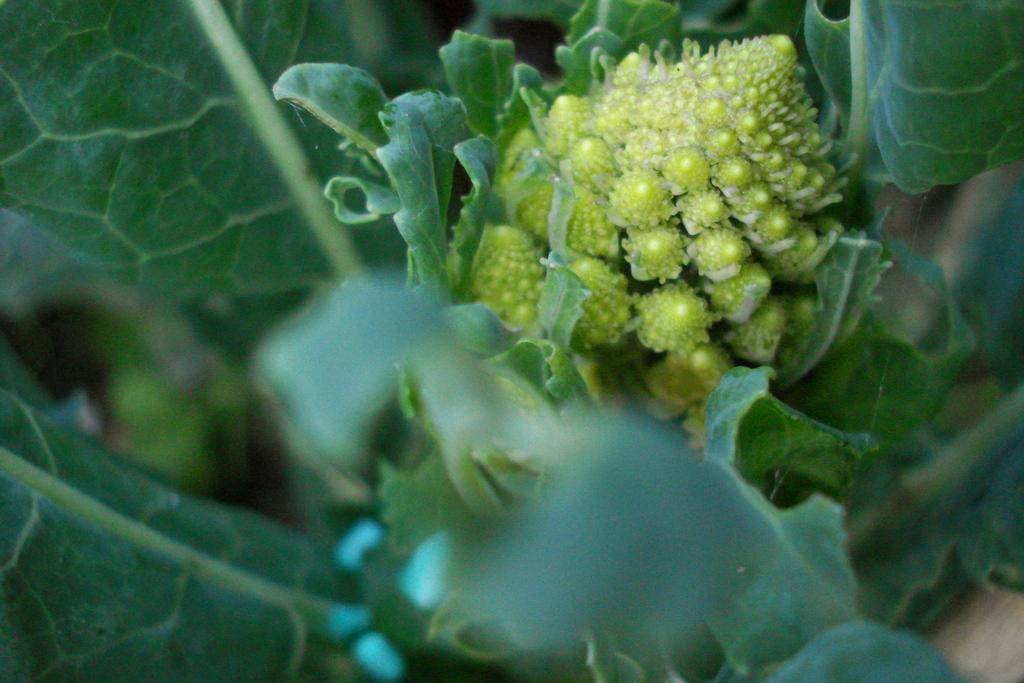What type of vegetation can be seen in the image? There are leaves in the image. Can you identify any specific plant or vegetable in the image? Yes, there is a broccoli in the image. What type of operation is being performed on the duck in the image? There is no duck present in the image, so no operation is being performed. 